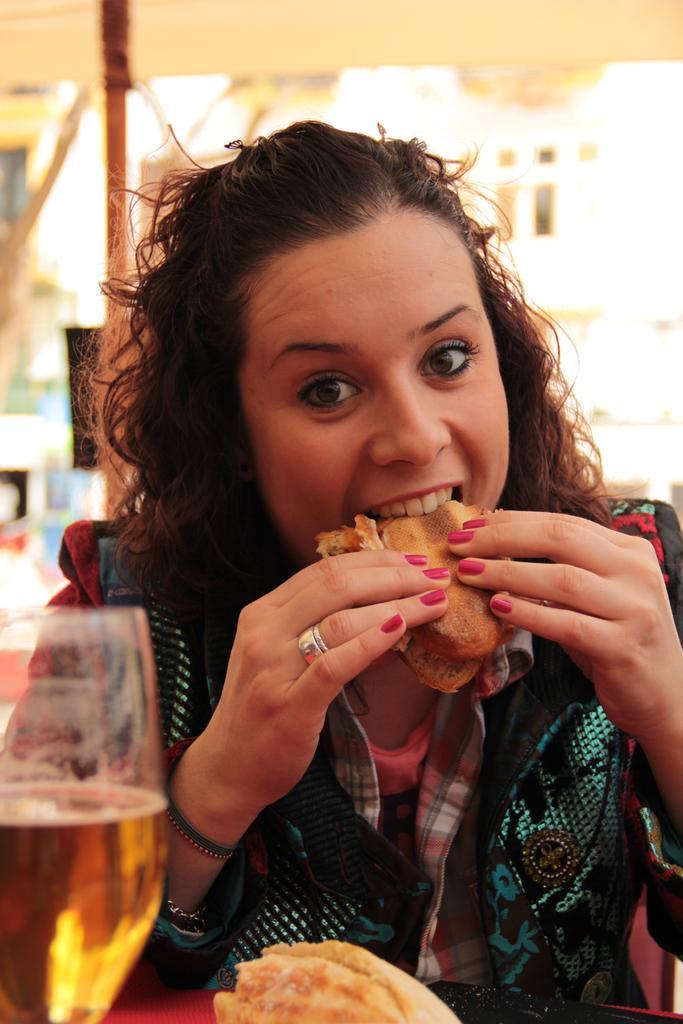Describe this image in one or two sentences. In this image in the middle, there is a woman, she wears a jacket, she is eating a sandwich, in front of her there is a table on that there is a glass of drink and bread. In the background there are buildings, tents. 